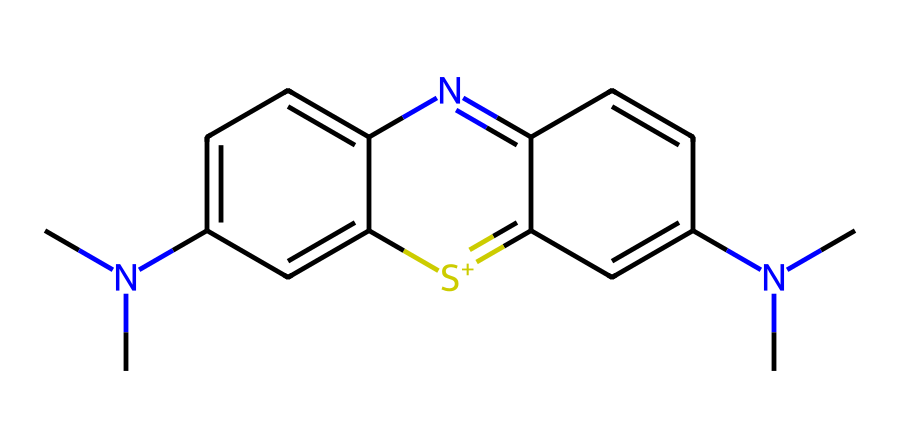What is the molecular formula of Methylene Blue? To determine the molecular formula, count the atoms for each element present in the SMILES notation: there are 16 carbon (C) atoms, 18 hydrogen (H) atoms, 2 nitrogen (N) atoms, and 1 sulfur (S) atom. Thus, the molecular formula is C16H18N3S.
Answer: C16H18N3S How many nitrogen atoms are present in the structure? By examining the SMILES representation, we can identify the nitrogen atoms, denoted by "N". In Methylene Blue, there are two nitrogen atoms present in the structure.
Answer: 2 What type of compound is Methylene Blue classified as? Based on its structure, which includes a phenothiazine core and nitrogen heteroatoms, Methylene Blue is classified as a thiazine dye.
Answer: thiazine dye What is the significance of the sulfur atom in Methylene Blue? The sulfur atom contributes to the properties and reactivity of Methylene Blue, stabilizing the molecular structure. In this case, the presence of sulfur plays a role in the dye's affinity for certain materials, which is valuable in various applications including OLED technology.
Answer: stabilizes structure How many rings are present in the molecular structure of Methylene Blue? Analyzing the SMILES data reveals several ring structures; tracing through the notation, there are three distinct rings present in the overall molecule.
Answer: 3 In the context of OLED technology, what role does Methylene Blue play? Methylene Blue acts as a dye and can be used as a charge transport material that influences the emission of light and enhances the efficiency of OLED devices.
Answer: charge transport material 